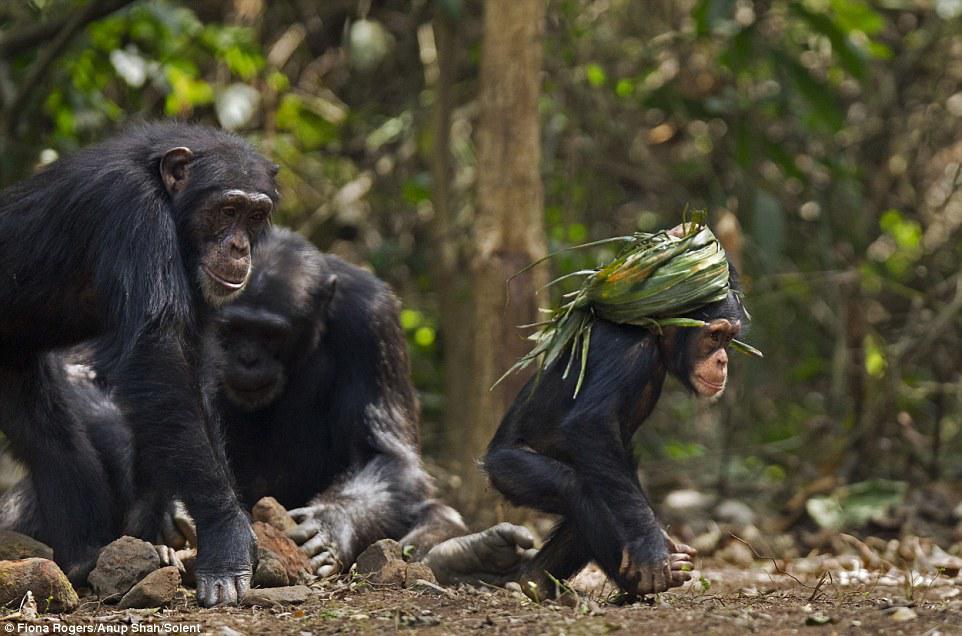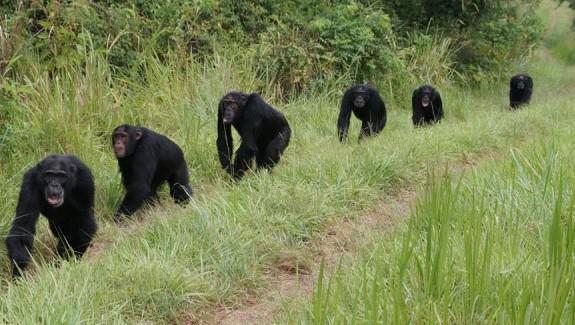The first image is the image on the left, the second image is the image on the right. Analyze the images presented: Is the assertion "There are more animals in the image on the right." valid? Answer yes or no. Yes. The first image is the image on the left, the second image is the image on the right. For the images displayed, is the sentence "At least one image shows a huddle of chimps in physical contact, and an image shows a forward-turned squatting chimp with one arm crossed over the other." factually correct? Answer yes or no. No. 